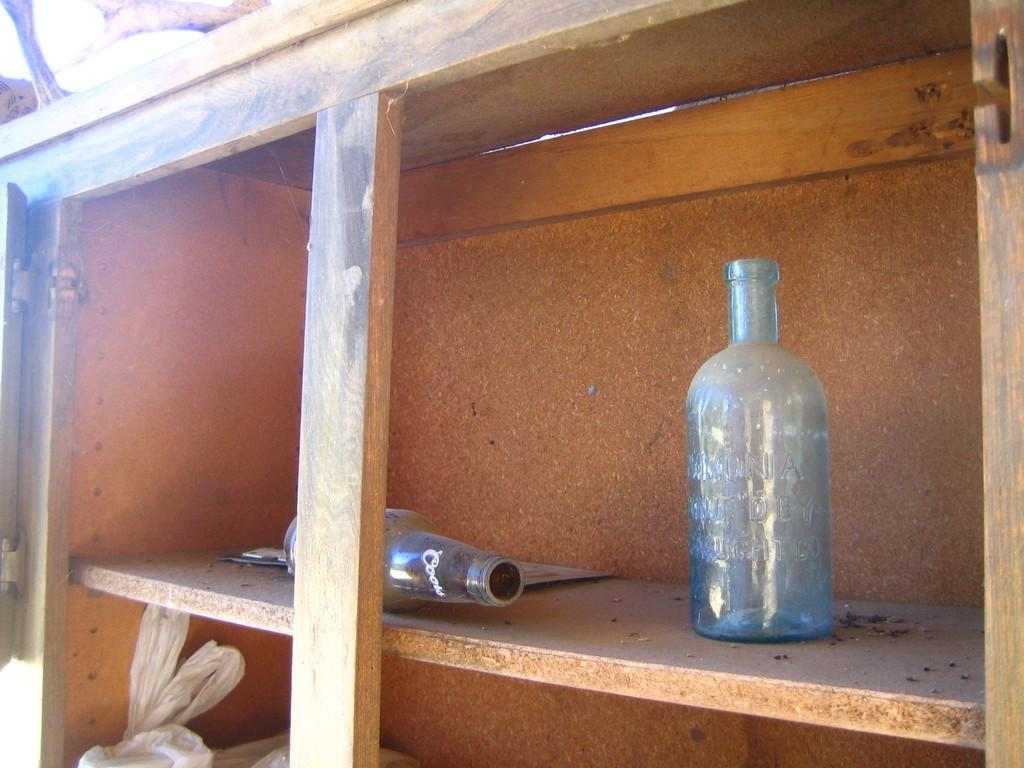What is the main object in the image? There is a rack in the image. What items are placed on the rack? There are two bottles and a white-colored bag on the rack. How many horses are visible in the image? There are no horses present in the image. What type of steel is used to make the rack in the image? The image does not provide information about the material used to make the rack, so it cannot be determined if steel is used. 